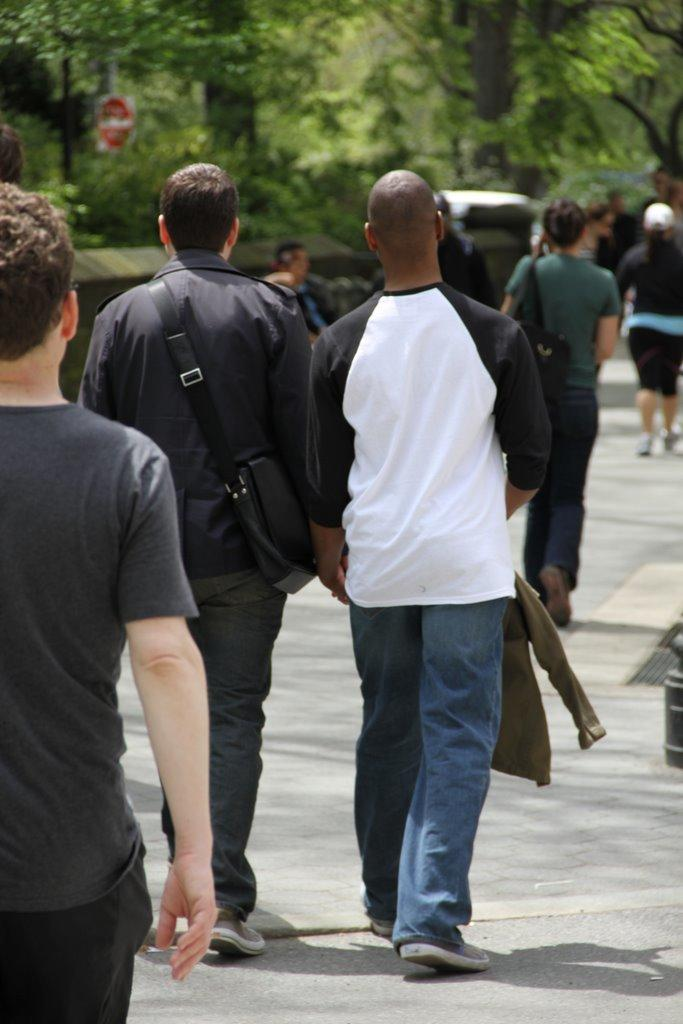What is happening in the image? There is a group of persons in the image, and they are walking on the road. What can be seen in the background of the image? There are trees in the background of the image. What type of breakfast is being served on the railway in the image? There is no railway or breakfast present in the image; it features a group of persons walking on the road with trees in the background. 